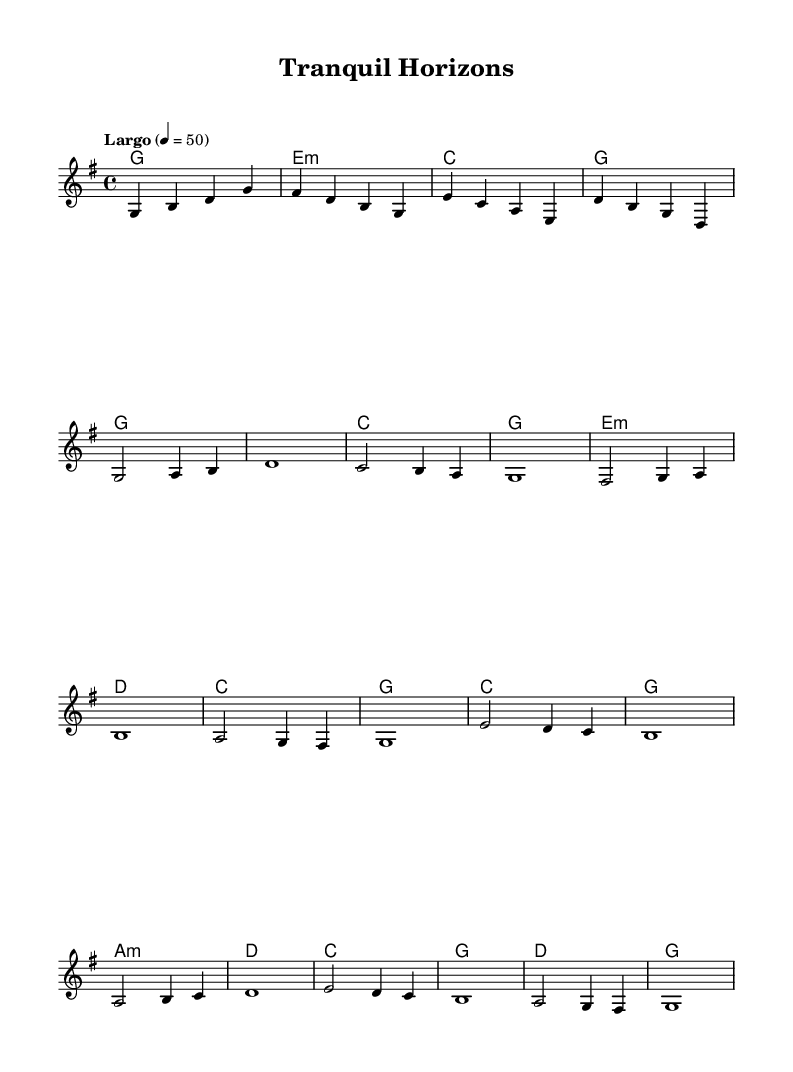What is the key signature of this music? The key signature is G major, which has one sharp (F#). This can be determined by looking at the key signature indicated at the beginning of the score.
Answer: G major What is the time signature of this music? The time signature shown in the sheet music is 4/4, which is indicated in the upper left corner. This means there are four beats in a measure, and each quarter note gets one beat.
Answer: 4/4 What is the tempo marking for this piece? The tempo marking is "Largo," which is presented above the first measure. Largo is traditionally a slow tempo, typically indicating a relaxed pace.
Answer: Largo How many measures are in the main theme section? The main theme section consists of 8 measures, identifiable from the beginning of the theme to the end of the first stanza marked in the score.
Answer: 8 What chord is played in the first measure? The first measure shows a G major chord, indicated by the chord symbol placed above the staff. This can be confirmed by looking at the harmony line where G is noted.
Answer: G Which note appears most frequently in the piano part? In the piano part, the note G appears most frequently, as it is played several times throughout the piece. Analyzing the melody reveals that G is a recurring note.
Answer: G What is the form of this piece? The piece follows a simple A-B-A structure, recognizable by the introduction, main theme, and bridge sections that return to the main theme at the end.
Answer: A-B-A 